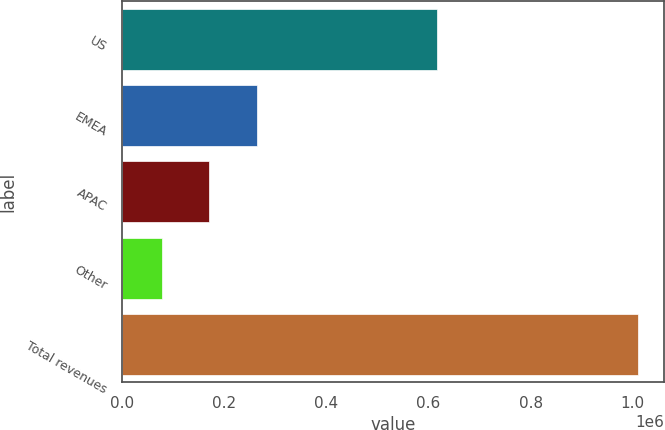Convert chart to OTSL. <chart><loc_0><loc_0><loc_500><loc_500><bar_chart><fcel>US<fcel>EMEA<fcel>APAC<fcel>Other<fcel>Total revenues<nl><fcel>616125<fcel>263901<fcel>170624<fcel>77347<fcel>1.01012e+06<nl></chart> 